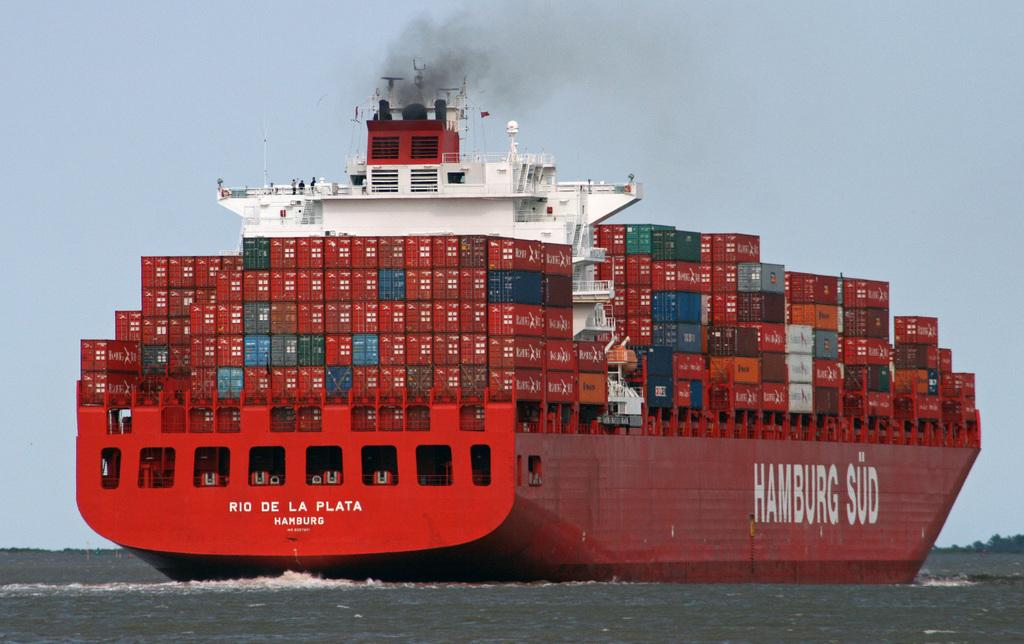What is the main subject of the image? The main subject of the image is water. What is located in the water? There is a boat in the water. What can be seen on the boat? There are boxes on the boat. Are there any people on the boat? Yes, there are people on the boat. What is visible at the top of the image? The sky is visible at the top of the image. What type of vegetable is being used to make the milk in the image? There is no vegetable or milk present in the image. What degree of difficulty is the boat facing in the image? There is no indication of the boat's difficulty level in the image. 